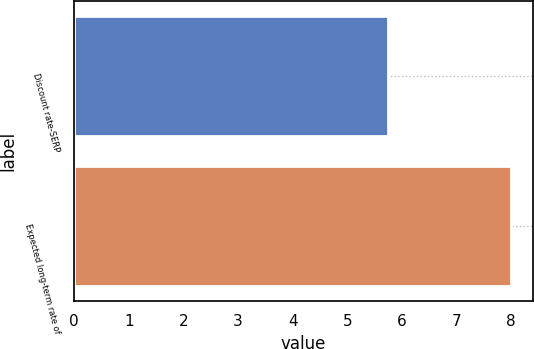Convert chart. <chart><loc_0><loc_0><loc_500><loc_500><bar_chart><fcel>Discount rate-SERP<fcel>Expected long-term rate of<nl><fcel>5.75<fcel>8<nl></chart> 